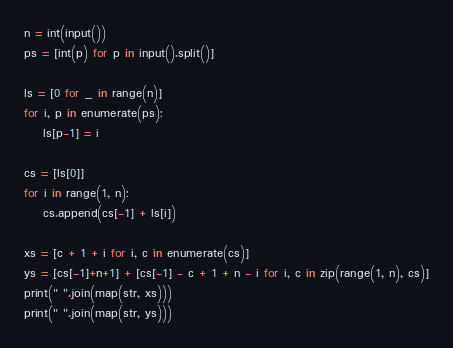Convert code to text. <code><loc_0><loc_0><loc_500><loc_500><_Python_>n = int(input())
ps = [int(p) for p in input().split()]

ls = [0 for _ in range(n)]
for i, p in enumerate(ps):
    ls[p-1] = i

cs = [ls[0]]
for i in range(1, n):
    cs.append(cs[-1] + ls[i])

xs = [c + 1 + i for i, c in enumerate(cs)]
ys = [cs[-1]+n+1] + [cs[-1] - c + 1 + n - i for i, c in zip(range(1, n), cs)]
print(" ".join(map(str, xs)))
print(" ".join(map(str, ys)))</code> 